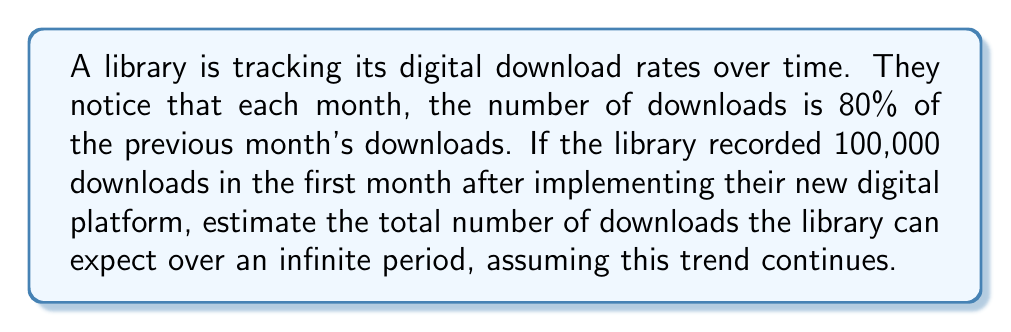Provide a solution to this math problem. To solve this problem, we need to recognize that this scenario represents a geometric series with an infinite number of terms. Let's break it down step-by-step:

1) First, let's identify the components of our geometric series:
   - First term, $a = 100,000$ (the number of downloads in the first month)
   - Common ratio, $r = 0.8$ (each month is 80% of the previous month)

2) The formula for the sum of an infinite geometric series is:

   $$S_{\infty} = \frac{a}{1-r}$$

   Where $S_{\infty}$ is the sum of the infinite series, $a$ is the first term, and $r$ is the common ratio.

3) This formula is valid only when $|r| < 1$, which is true in our case as $0.8 < 1$.

4) Let's substitute our values into the formula:

   $$S_{\infty} = \frac{100,000}{1-0.8}$$

5) Simplify:
   $$S_{\infty} = \frac{100,000}{0.2}$$

6) Calculate:
   $$S_{\infty} = 500,000$$

Therefore, the library can expect a total of 500,000 downloads over an infinite period if this trend continues.

This result makes sense in the context of library science and digitization. As physical visits to libraries decrease, digital downloads become increasingly important. This calculation helps librarians understand the long-term impact of their digital initiatives and plan accordingly for server capacity and digital resource allocation.
Answer: 500,000 downloads 